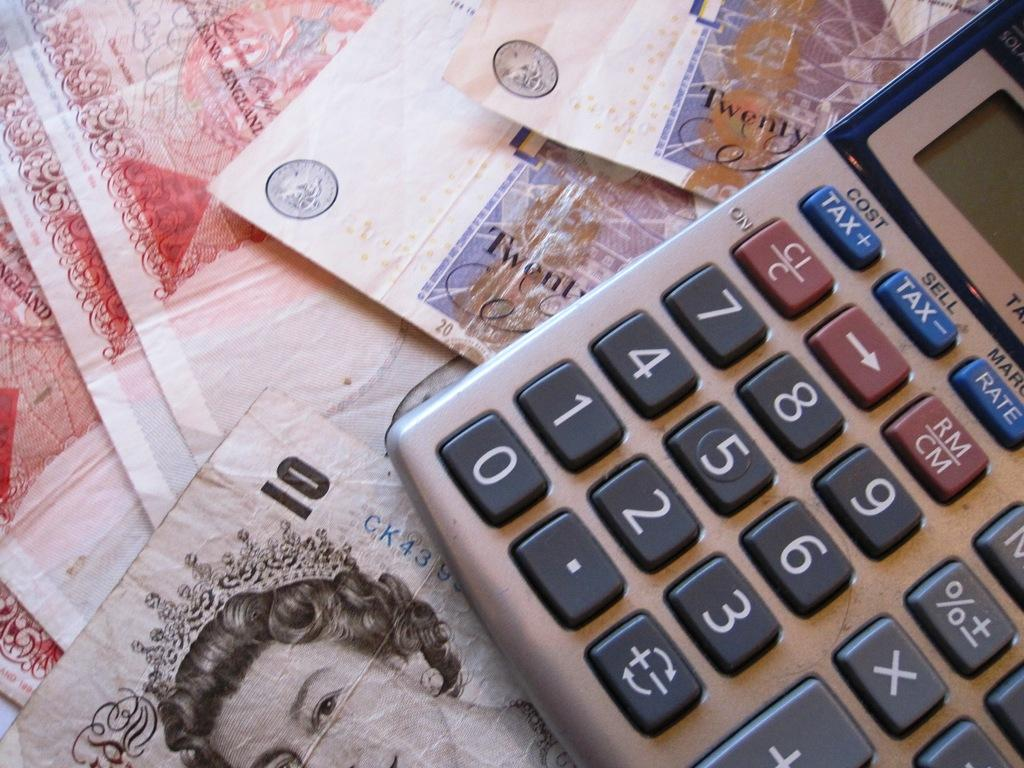<image>
Present a compact description of the photo's key features. A calculator is on top of Great British pound bills in denominations of twenty and ten. 